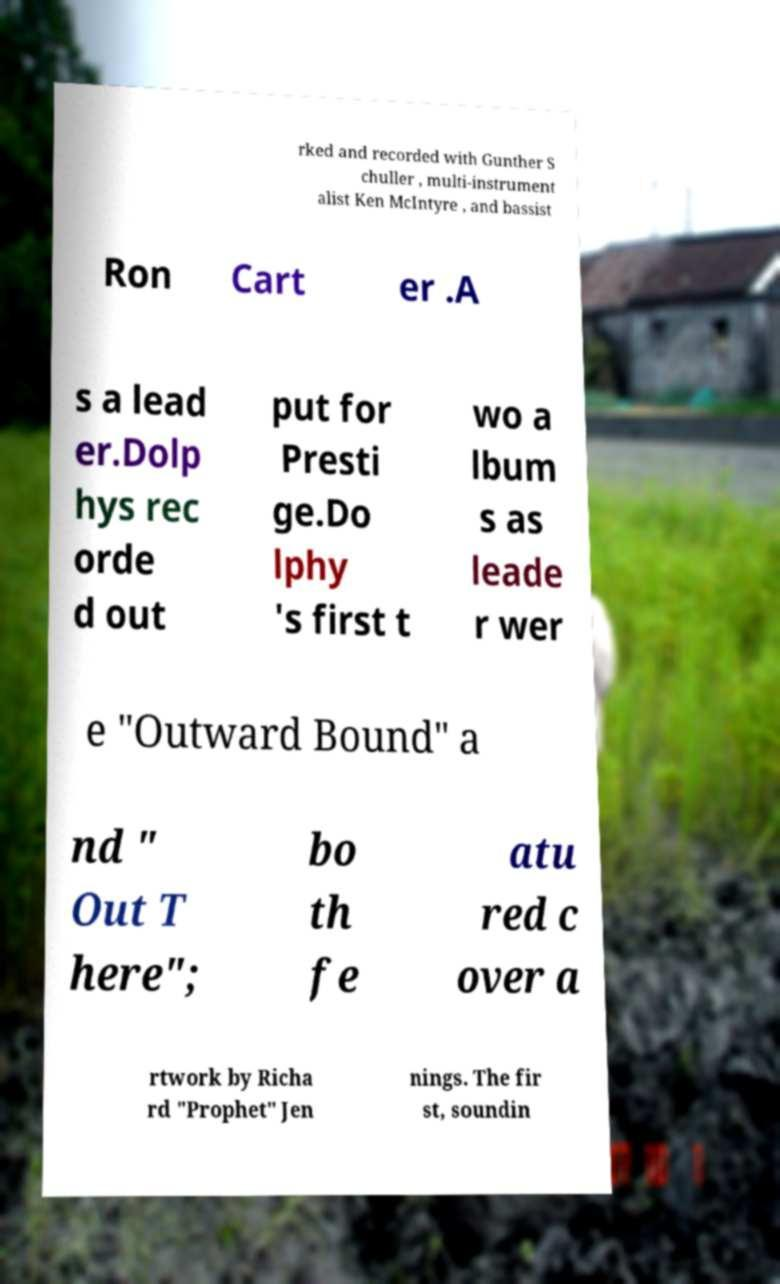Could you assist in decoding the text presented in this image and type it out clearly? rked and recorded with Gunther S chuller , multi-instrument alist Ken McIntyre , and bassist Ron Cart er .A s a lead er.Dolp hys rec orde d out put for Presti ge.Do lphy 's first t wo a lbum s as leade r wer e "Outward Bound" a nd " Out T here"; bo th fe atu red c over a rtwork by Richa rd "Prophet" Jen nings. The fir st, soundin 